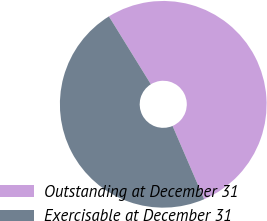Convert chart. <chart><loc_0><loc_0><loc_500><loc_500><pie_chart><fcel>Outstanding at December 31<fcel>Exercisable at December 31<nl><fcel>52.33%<fcel>47.67%<nl></chart> 